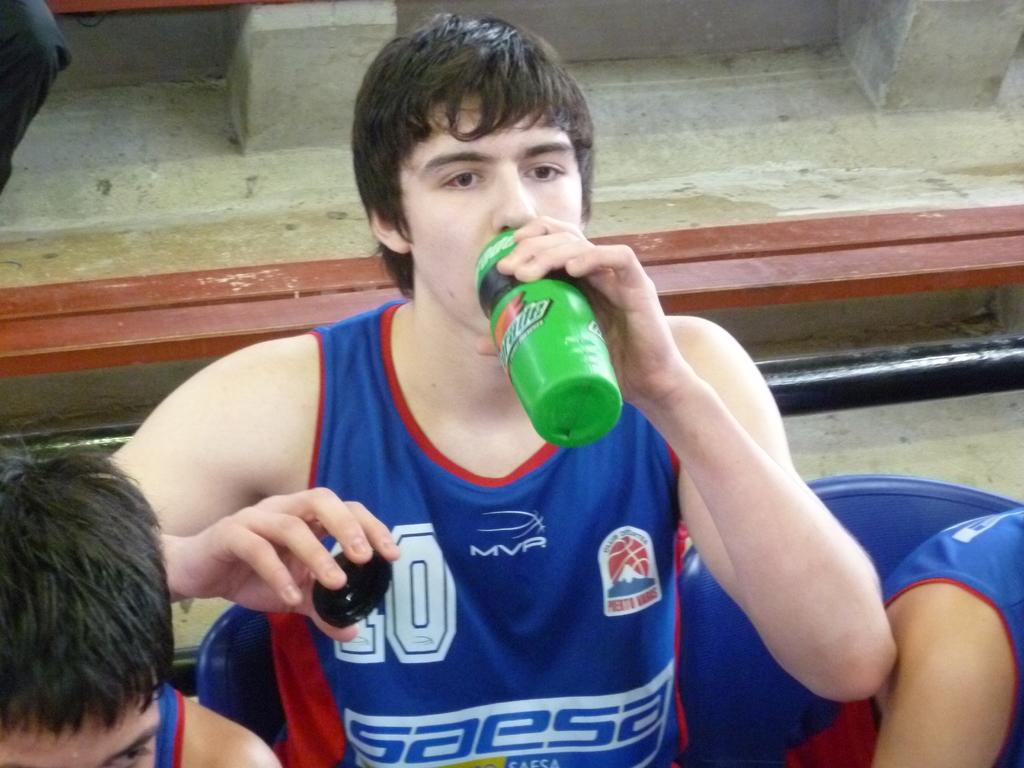<image>
Summarize the visual content of the image. a person drinking out of a Gatorade bottle 